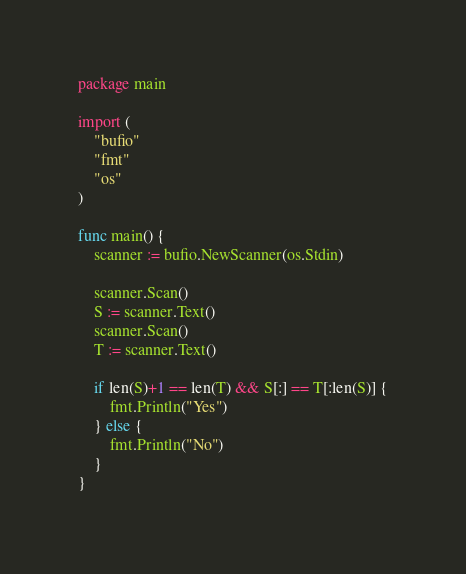Convert code to text. <code><loc_0><loc_0><loc_500><loc_500><_Go_>package main

import (
	"bufio"
	"fmt"
	"os"
)

func main() {
	scanner := bufio.NewScanner(os.Stdin)

	scanner.Scan()
	S := scanner.Text()
	scanner.Scan()
	T := scanner.Text()

	if len(S)+1 == len(T) && S[:] == T[:len(S)] {
		fmt.Println("Yes")
	} else {
		fmt.Println("No")
	}
}
</code> 